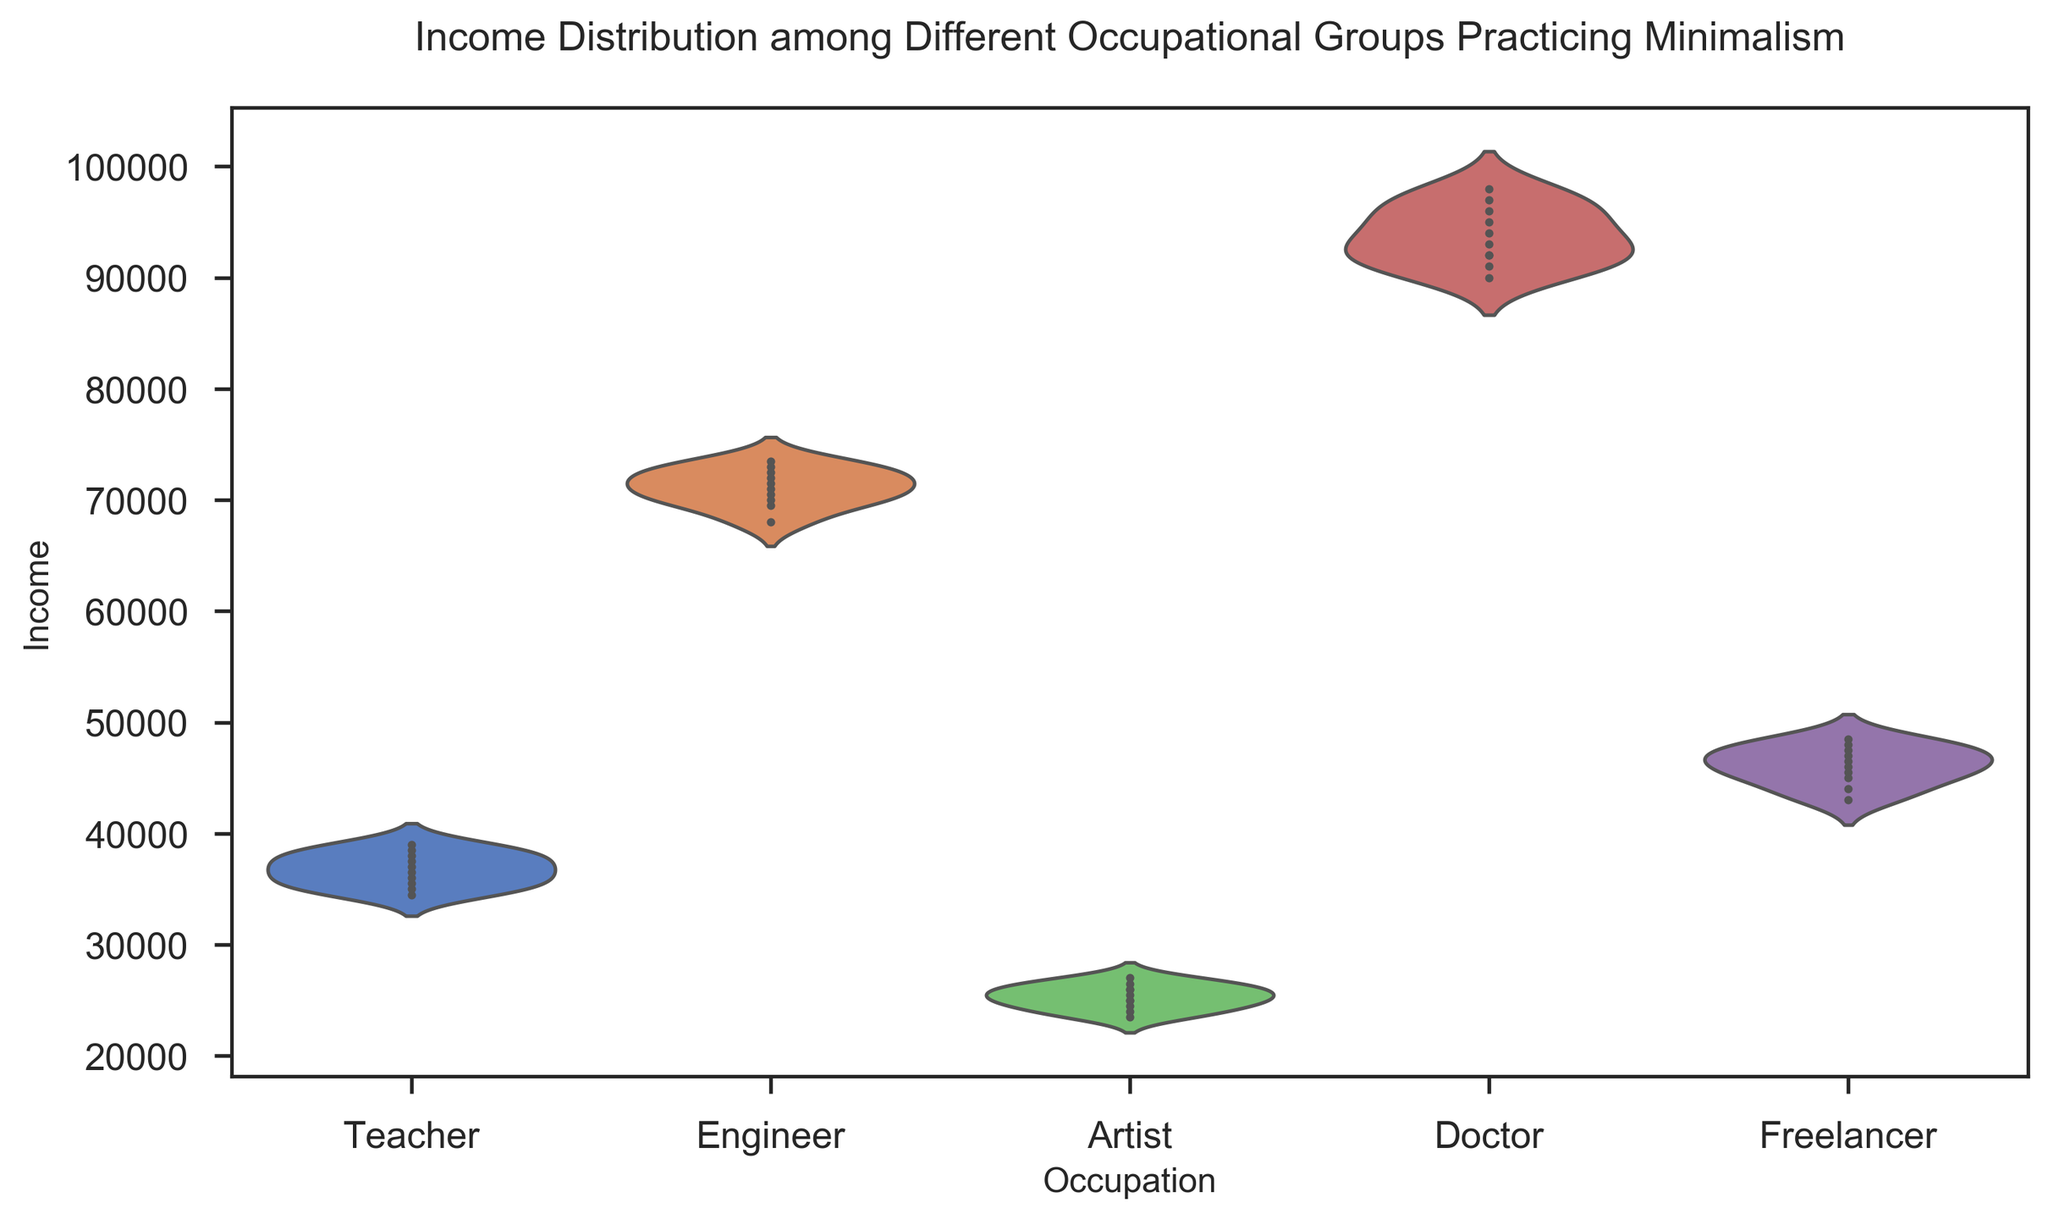Which occupation group has the highest median income? To find the highest median income, observe the central line showing the data's median for each occupation. The line in the violin plot for 'Doctor' is at the highest income value.
Answer: Doctor Which occupation group shows the greatest spread in income? The greatest spread in income is indicated by the widest and tallest violin shape. The 'Doctor' occupation group has the widest and tallest violin shape, suggesting the most spread in income.
Answer: Doctor Between 'Teacher' and 'Freelancer', which group has a higher average income? To determine the higher average income, compare the central density of the two groups. 'Teacher' has a higher overall position than 'Freelancer' on the income axis.
Answer: Teacher What is the approximate median income for the 'Engineer' group? The median is indicated by the central white dot in the violin plot for 'Engineer'. This dot appears around the value of $71000.
Answer: $71000 Which two occupation groups have the closest minimum incomes? Compare the lowest points of the violin plots for each occupation group. 'Teacher' and 'Artist' have close minimum incomes around $35000 and $23500 respectively.
Answer: Teacher and Artist Is the income distribution for the 'Artist' group skewed or symmetric? Examine the shape of the violin plot for 'Artist'. The density is higher on the lower income side, which indicates a skewed distribution towards lower incomes.
Answer: Skewed How does the maximum income for the 'Freelancer' group compare to the median income for the 'Doctor' group? The maximum income in the 'Freelancer' plot is around $48500, while the median income in the 'Doctor' plot is around $92000.
Answer: Freelancer's maximum is less than Doctor's median Which occupation group has a wider income range, 'Teacher' or 'Engineer'? By comparing the heights of the violin plots, we can see that 'Engineer' has a taller plot, suggesting a wider income range than 'Teacher'.
Answer: Engineer 